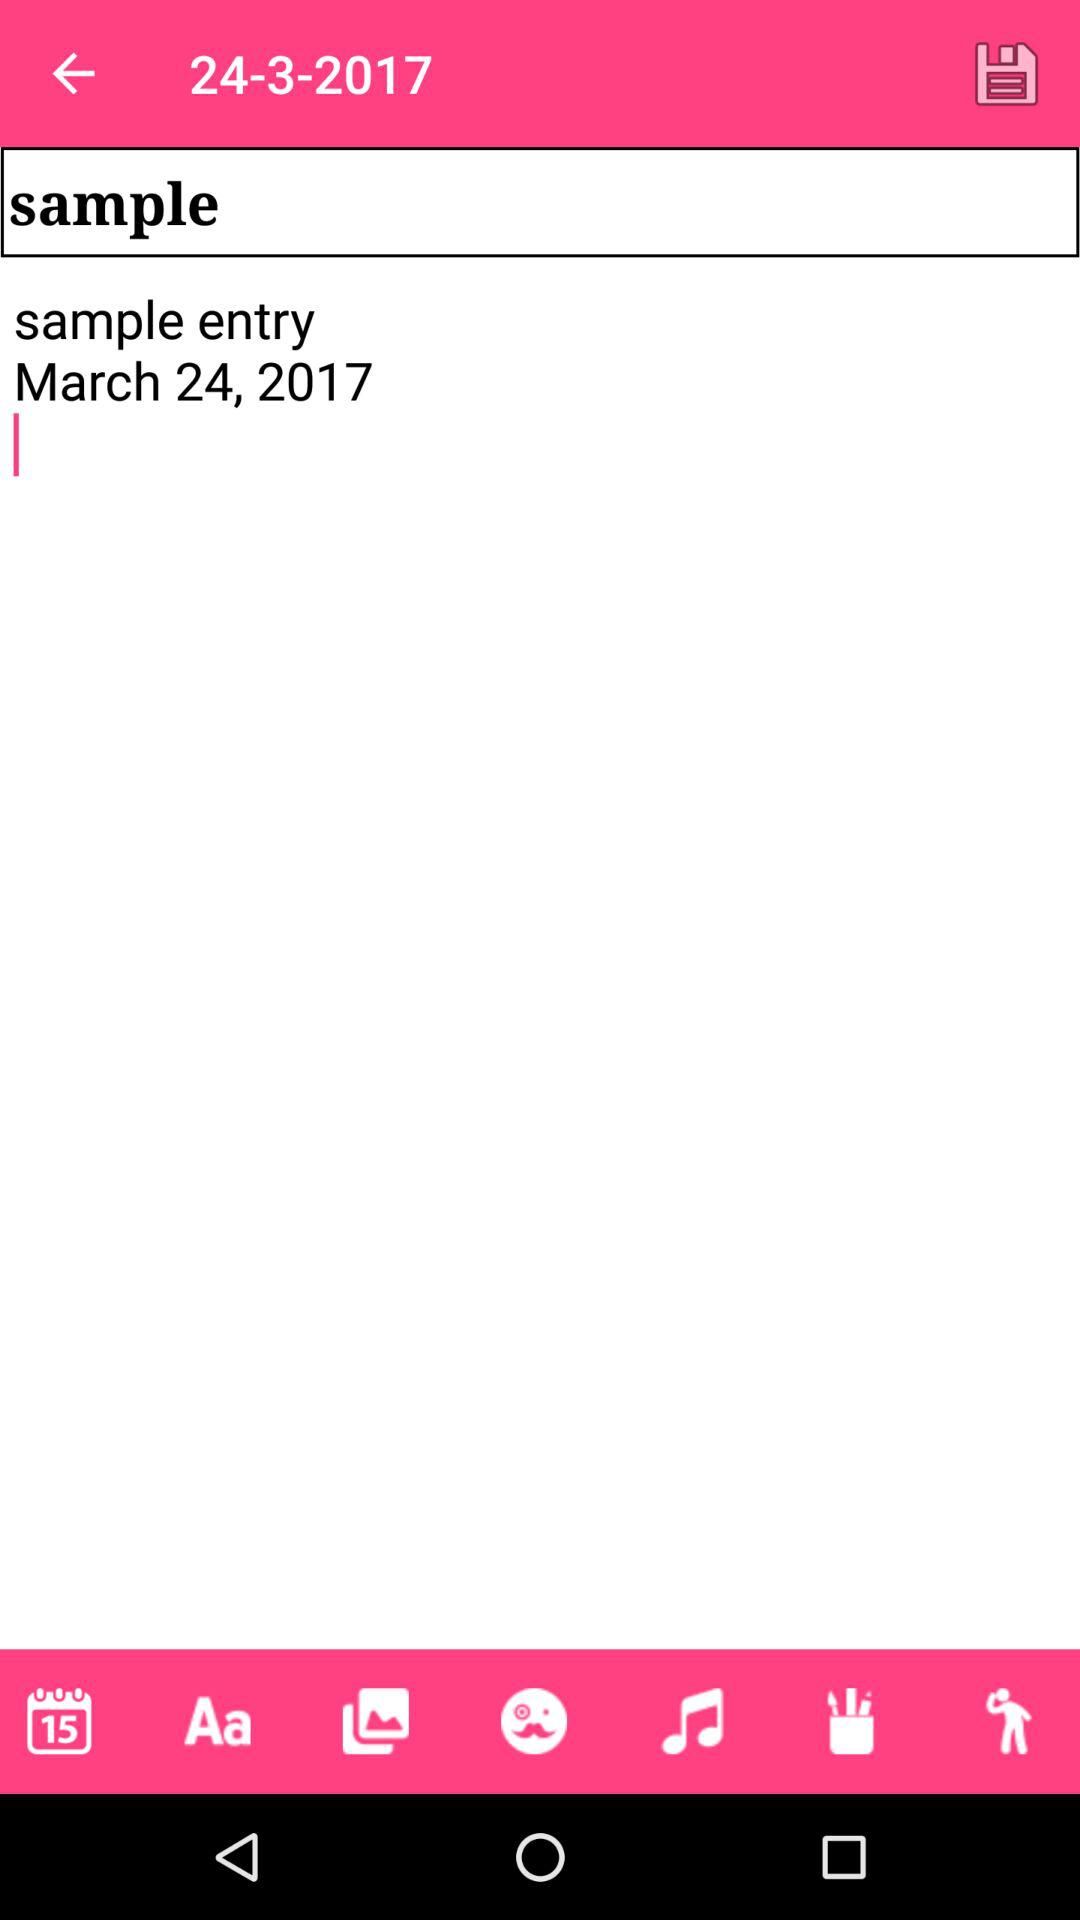At what time was the sample entry posted?
When the provided information is insufficient, respond with <no answer>. <no answer> 